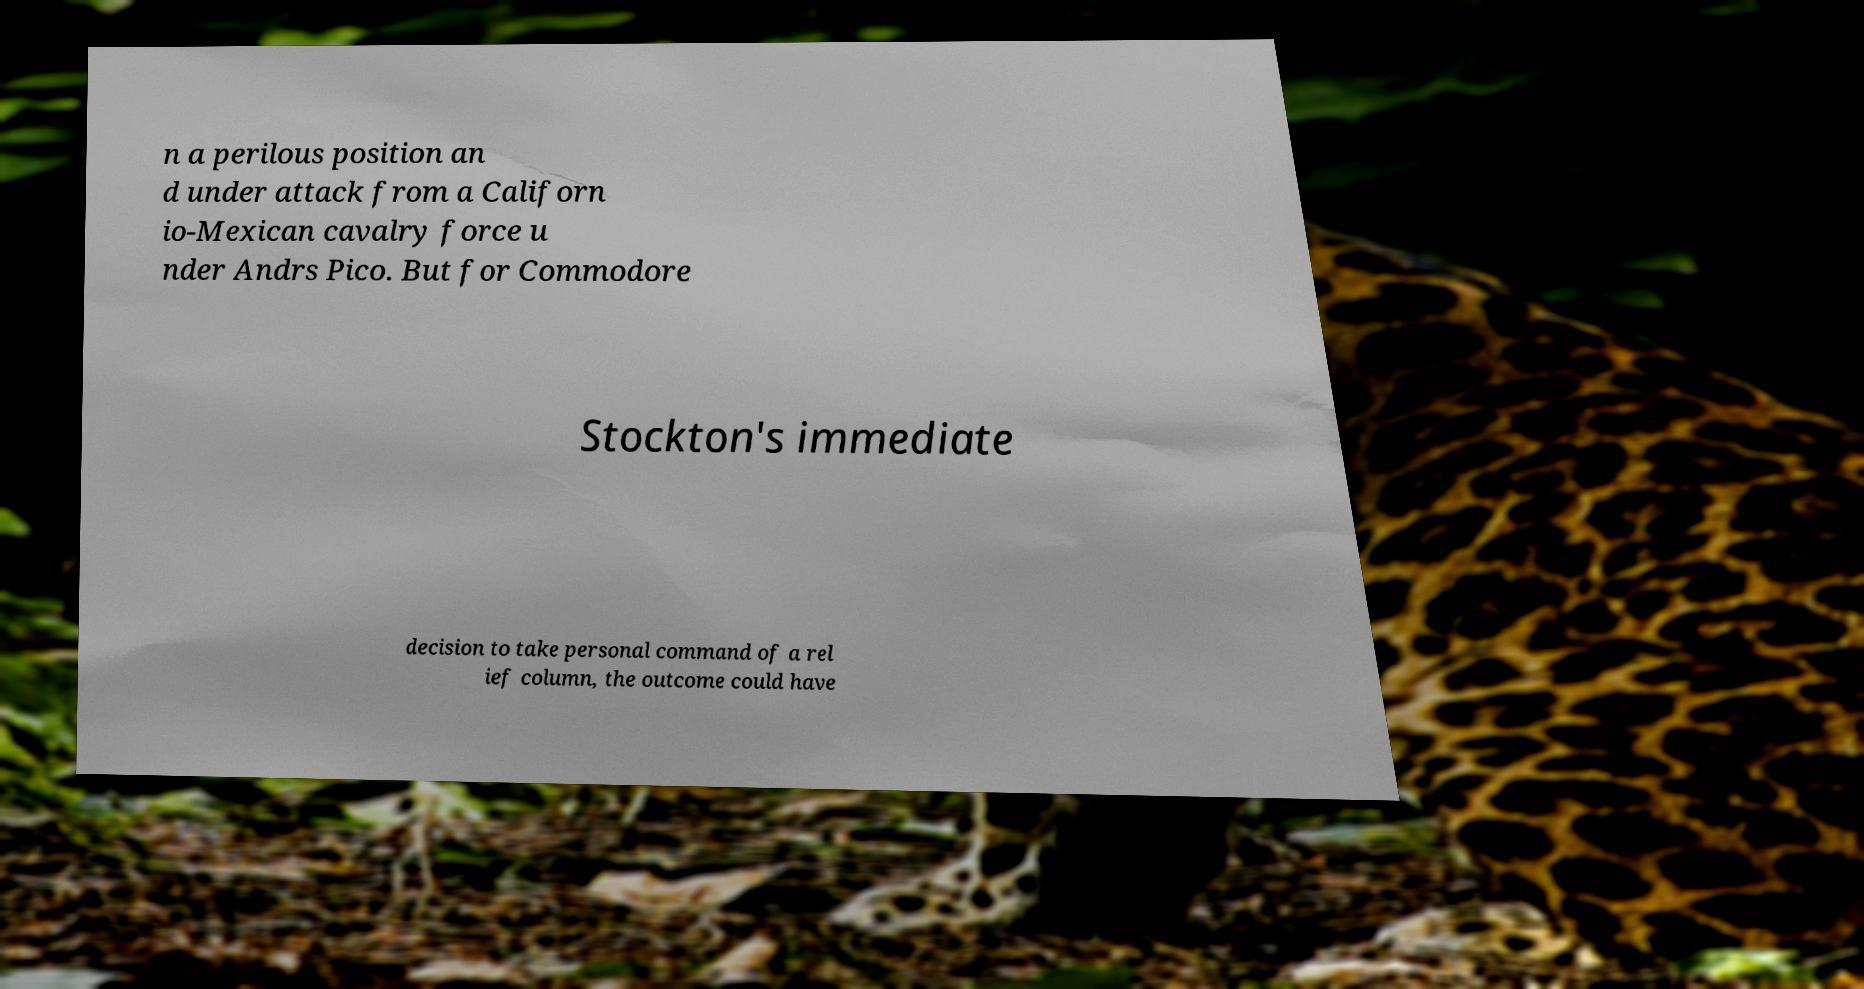Could you assist in decoding the text presented in this image and type it out clearly? n a perilous position an d under attack from a Californ io-Mexican cavalry force u nder Andrs Pico. But for Commodore Stockton's immediate decision to take personal command of a rel ief column, the outcome could have 